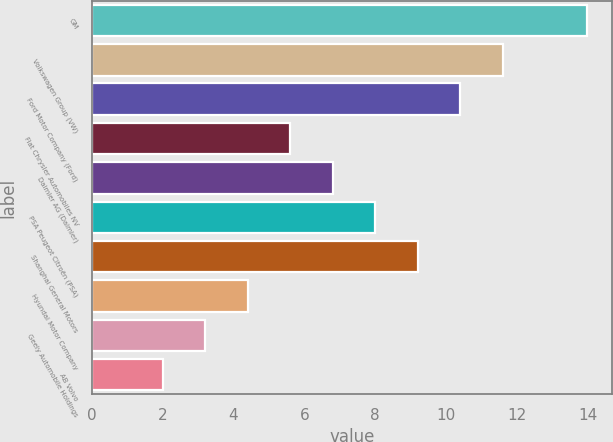<chart> <loc_0><loc_0><loc_500><loc_500><bar_chart><fcel>GM<fcel>Volkswagen Group (VW)<fcel>Ford Motor Company (Ford)<fcel>Fiat Chrysler Automobiles NV<fcel>Daimler AG (Daimler)<fcel>PSA Peugeot Citroën (PSA)<fcel>Shanghai General Motors<fcel>Hyundai Motor Company<fcel>Geely Automobile Holdings<fcel>AB Volvo<nl><fcel>14<fcel>11.6<fcel>10.4<fcel>5.6<fcel>6.8<fcel>8<fcel>9.2<fcel>4.4<fcel>3.2<fcel>2<nl></chart> 